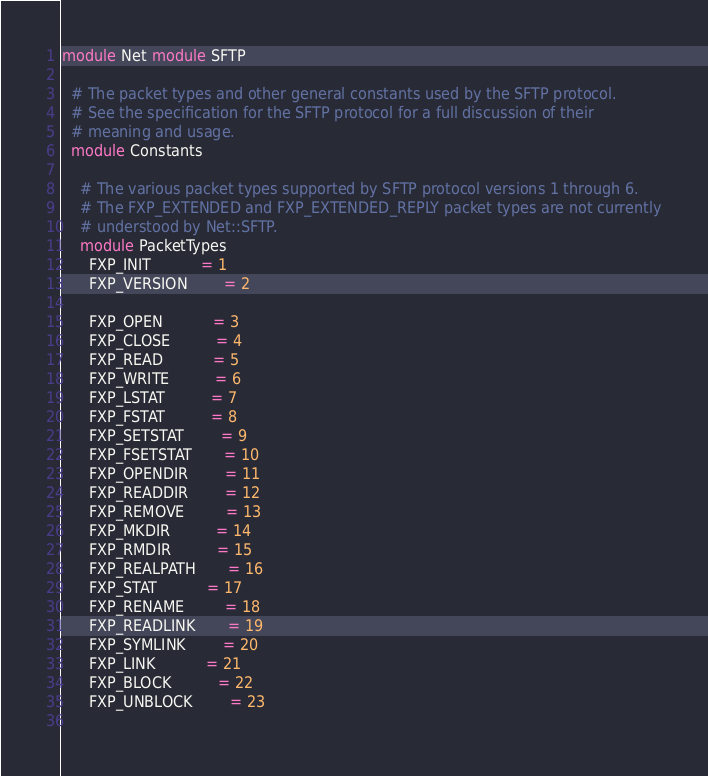Convert code to text. <code><loc_0><loc_0><loc_500><loc_500><_Ruby_>module Net module SFTP

  # The packet types and other general constants used by the SFTP protocol.
  # See the specification for the SFTP protocol for a full discussion of their
  # meaning and usage.
  module Constants

    # The various packet types supported by SFTP protocol versions 1 through 6.
    # The FXP_EXTENDED and FXP_EXTENDED_REPLY packet types are not currently
    # understood by Net::SFTP.
    module PacketTypes
      FXP_INIT           = 1
      FXP_VERSION        = 2
                         
      FXP_OPEN           = 3
      FXP_CLOSE          = 4
      FXP_READ           = 5
      FXP_WRITE          = 6
      FXP_LSTAT          = 7
      FXP_FSTAT          = 8
      FXP_SETSTAT        = 9
      FXP_FSETSTAT       = 10
      FXP_OPENDIR        = 11
      FXP_READDIR        = 12
      FXP_REMOVE         = 13
      FXP_MKDIR          = 14
      FXP_RMDIR          = 15
      FXP_REALPATH       = 16
      FXP_STAT           = 17
      FXP_RENAME         = 18
      FXP_READLINK       = 19
      FXP_SYMLINK        = 20
      FXP_LINK           = 21
      FXP_BLOCK          = 22
      FXP_UNBLOCK        = 23
                         </code> 